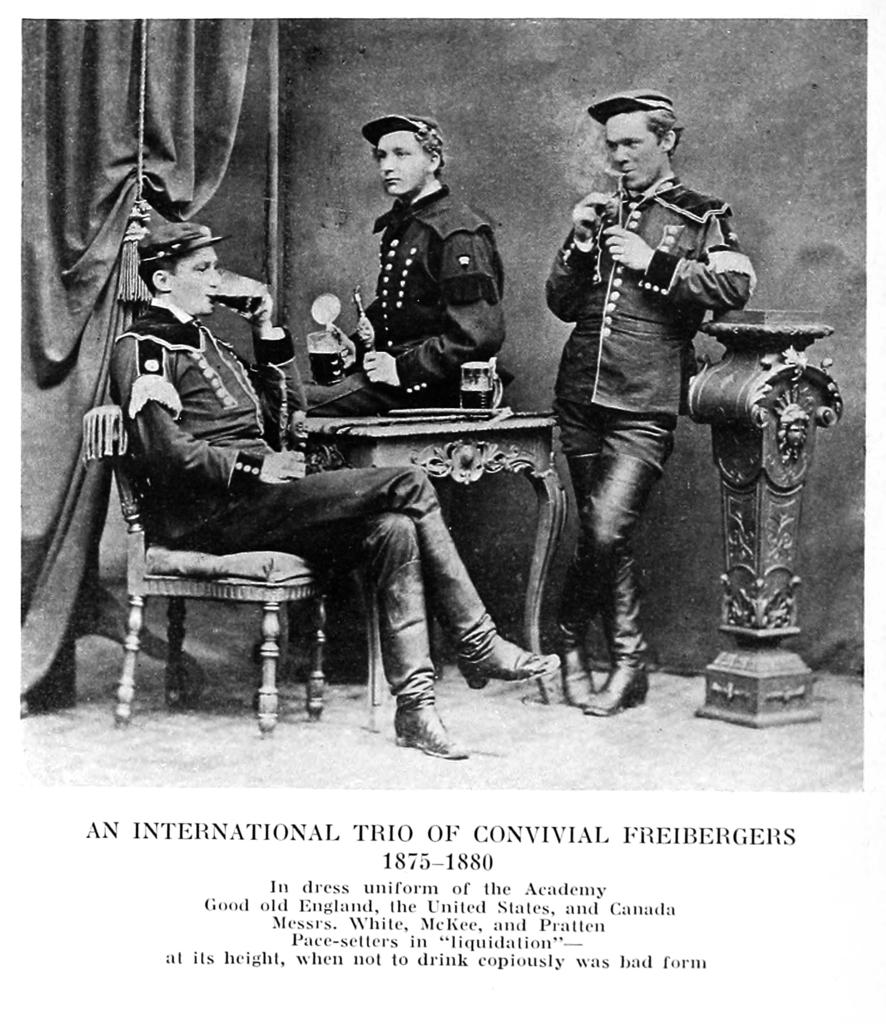What is present on a surface in the image? There is a poster in the image. Where are some people located in the image? There are people on the floor in the image. What type of furniture can be seen in the image? There is a table and a chair in the image. What can be found on the objects in the image? There are objects visible in the image, and some of them have text on them. Can you see a family member giving a kiss to someone in the image? There is no family member giving a kiss to someone in the image. What type of animal's tail can be seen in the image? There are no animals or tails present in the image. 